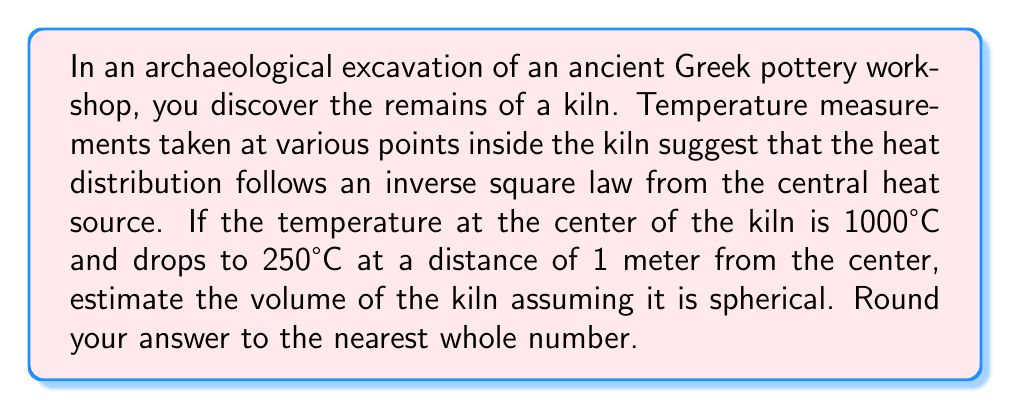Could you help me with this problem? To solve this problem, we'll follow these steps:

1) First, we need to determine the radius of the kiln. We can use the inverse square law for this:

   $$T = \frac{k}{r^2}$$

   where $T$ is temperature, $k$ is a constant, and $r$ is the distance from the center.

2) We know two points: 
   At the center (r = 0 m): T = 1000°C
   At 1 meter (r = 1 m): T = 250°C

3) Using the second point, we can find $k$:

   $$250 = \frac{k}{1^2}$$
   $$k = 250$$

4) Now, we can find the radius where the temperature drops to a reasonable firing temperature for pottery, say 600°C:

   $$600 = \frac{250}{r^2}$$
   $$r^2 = \frac{250}{600}$$
   $$r = \sqrt{\frac{250}{600}} \approx 0.645 \text{ meters}$$

5) Now that we have the radius, we can calculate the volume of the spherical kiln using the formula:

   $$V = \frac{4}{3}\pi r^3$$

6) Plugging in our radius:

   $$V = \frac{4}{3}\pi (0.645)^3$$
   $$V \approx 1.12 \text{ cubic meters}$$

7) Rounding to the nearest whole number:

   $$V \approx 1 \text{ cubic meter}$$
Answer: 1 cubic meter 